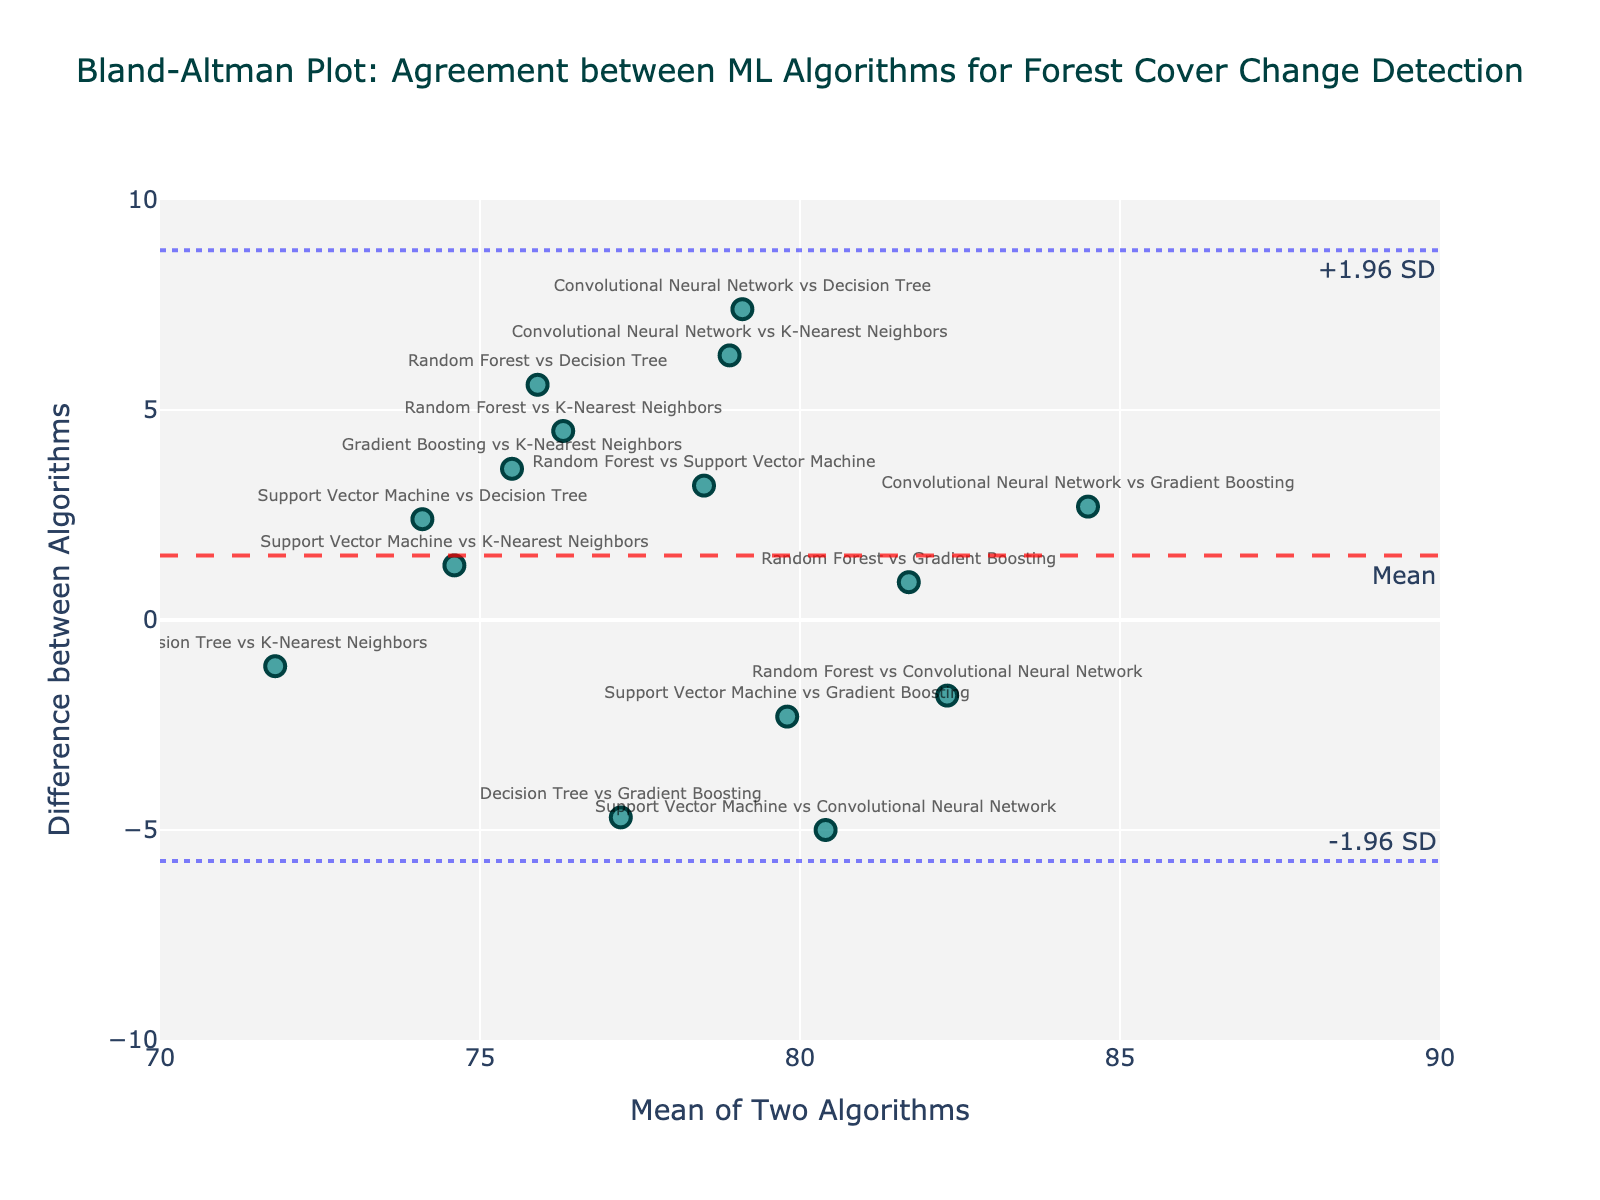What does the red dashed line in the plot represent? The red dashed line indicates the mean difference between the pairs of algorithms. It is a horizontal reference line that helps visualize the average bias between the algorithms.
Answer: Mean difference Which algorithms have the smallest difference in detecting forest cover change? By looking at the y-axis (Difference) values, the smallest difference is 0.9 between Random Forest and Gradient Boosting.
Answer: Random Forest and Gradient Boosting What is the difference between the Random Forest and Decision Tree algorithms? Locate the point labeled "Random Forest vs Decision Tree" on the plot and check its y-value. The difference is 5.6.
Answer: 5.6 How many pairs of algorithms have a positive difference? Count the number of points above the x-axis (y > 0). There are 8 points: Random Forest vs Support Vector Machine, Random Forest vs Decision Tree, Random Forest vs Gradient Boosting, Random Forest vs K-Nearest Neighbors, Support Vector Machine vs Decision Tree, Convolutional Neural Network vs Gradient Boosting, Convolutional Neural Network vs K-Nearest Neighbors, and Gradient Boosting vs K-Nearest Neighbors.
Answer: 8 Which pairs of algorithms have differences greater than the upper limit (+1.96 SD)? Identify the points above the upper dashed blue line, which represents the mean difference + 1.96 standard deviations. These points are: Convolutional Neural Network vs Decision Tree and Convolutional Neural Network vs K-Nearest Neighbors.
Answer: Convolutional Neural Network vs Decision Tree, Convolutional Neural Network vs K-Nearest Neighbors What is the range of the x-axis values on the plot? The x-axis covers the mean of two algorithms, ranging from about 70 to 90, as noted by the x-axis labels and the plotted points' horizontal spread.
Answer: 70 to 90 Which algorithm pair has the largest absolute difference? Locate the point with the highest absolute y-value. The point labeled "Convolutional Neural Network vs Decision Tree" has a difference of 7.4, which is the largest.
Answer: Convolutional Neural Network and Decision Tree What does the plot title tell us about the purpose of this Bland-Altman plot? The title "Bland-Altman Plot: Agreement between ML Algorithms for Forest Cover Change Detection" indicates that the plot is used to assess the agreement between different machine learning algorithms in detecting forest cover changes.
Answer: Assessing agreement Are there any algorithm pairs with negative differences, and what does it imply? Yes, there are points below the x-axis (y < 0), indicating a negative difference. This implies that the first algorithm detects a lower value compared to the second algorithm. Examples include Random Forest vs Convolutional Neural Network (-1.8) and Support Vector Machine vs Convolutional Neural Network (-5.0).
Answer: Yes, it implies first algorithm lower Is there any pair of algorithms that falls exactly on the mean difference line? Check if any point falls directly on the red dashed line representing the mean difference. None of the points fall exactly on this line.
Answer: No 